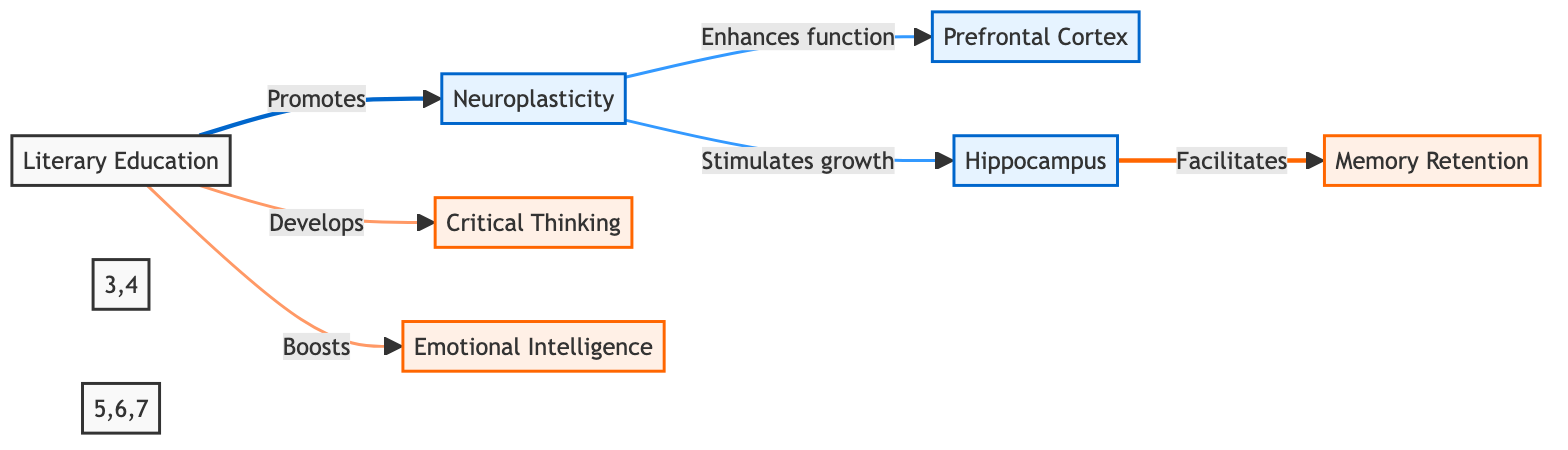What is the first node in the diagram? The first node in the diagram is labeled "Literary Education," which is the starting point for the process of cognitive development presented in the flowchart.
Answer: Literary Education How many cognitive outcomes are represented in the diagram? There are three cognitive outcomes represented in the diagram: Critical Thinking, Emotional Intelligence, and Memory Retention. By counting these nodes, we can determine the total number of cognitive outcomes.
Answer: Three Which node is directly affected by Neuroplasticity? The node "Prefrontal Cortex" is directly affected by Neuroplasticity, indicated by the arrow connecting Neuroplasticity to Prefrontal Cortex.
Answer: Prefrontal Cortex What does the Hippocampus facilitate according to the diagram? The Hippocampus facilitates Memory Retention, as indicated by the directional flow from the Hippocampus to the Memory Retention node.
Answer: Memory Retention What effect does Literary Education have on Emotional Intelligence? Literary Education boosts Emotional Intelligence, as shown by the directed edge from Literary Education to Emotional Intelligence.
Answer: Boosts What is the connection between Neuroplasticity and the Prefrontal Cortex? Neuroplasticity enhances the function of the Prefrontal Cortex, as stated in the diagram’s labeling of the relationship between these two nodes.
Answer: Enhances function What role does Neuroplasticity play in the growth of the Hippocampus? Neuroplasticity stimulates the growth of the Hippocampus, illustrated by the diagram's arrow indicating this causal relationship.
Answer: Stimulates growth Which color represents the nodes pertaining to cognition? The nodes related to cognition are represented in a light orange color, distinctively labeled with the class "cognitive" in the diagram for easy identification.
Answer: Light orange What process does Neuroplasticity primarily promote according to this diagram? Neuroplasticity primarily promotes the process of cognitive enhancement, specifically through changes in the brain related to memory and thought processes as denoted in the flowchart.
Answer: Cognitive enhancement 